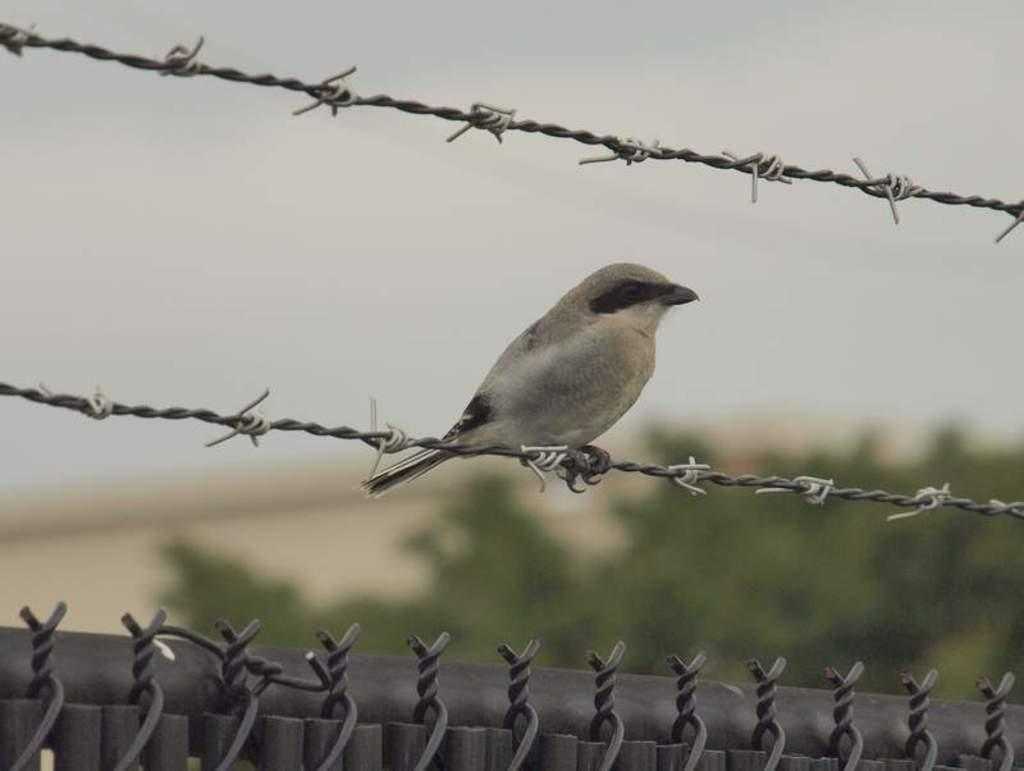What type of animal can be seen in the image? There is a bird in the image. Where is the bird located? The bird is sitting on a wire fencing. Can you describe the background of the image? The background of the image is blurred. What type of bead is the bird holding in its beak in the image? There is no bead present in the image; the bird is sitting on a wire fencing. Can you tell me how many friends the bird has in the image? There is no indication of friends or social interactions in the image; it simply shows a bird sitting on a wire fencing. 